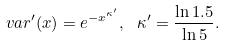Convert formula to latex. <formula><loc_0><loc_0><loc_500><loc_500>\ v a r ^ { \prime } ( x ) = e ^ { - x ^ { \kappa ^ { \prime } } } , \ \kappa ^ { \prime } = \frac { \ln 1 . 5 } { \ln 5 } .</formula> 